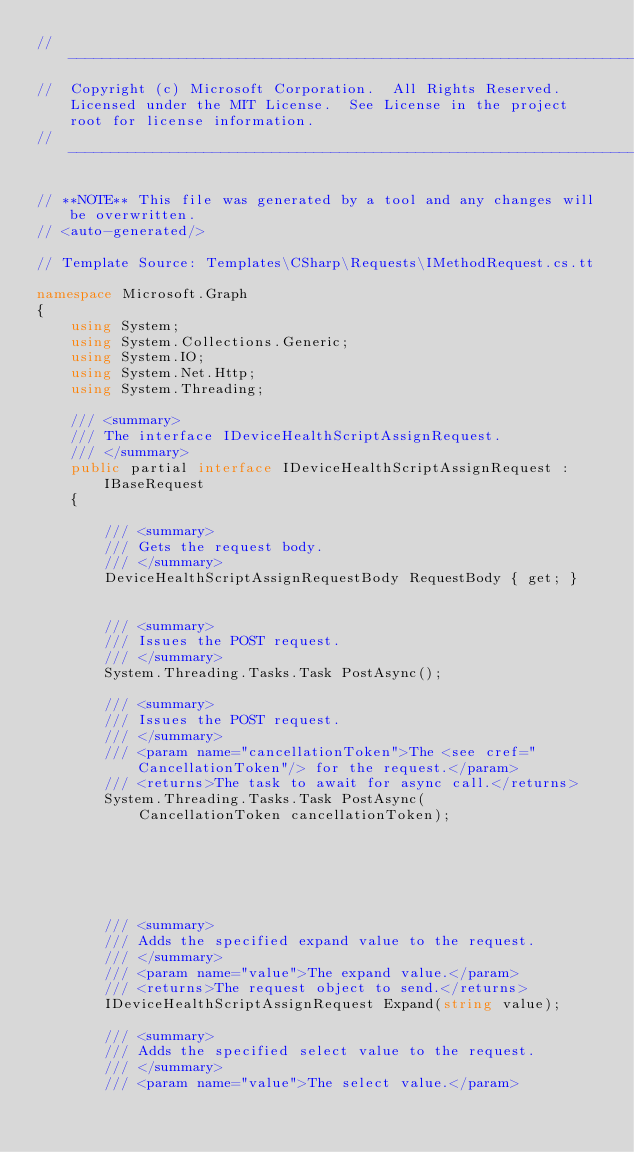<code> <loc_0><loc_0><loc_500><loc_500><_C#_>// ------------------------------------------------------------------------------
//  Copyright (c) Microsoft Corporation.  All Rights Reserved.  Licensed under the MIT License.  See License in the project root for license information.
// ------------------------------------------------------------------------------

// **NOTE** This file was generated by a tool and any changes will be overwritten.
// <auto-generated/>

// Template Source: Templates\CSharp\Requests\IMethodRequest.cs.tt

namespace Microsoft.Graph
{
    using System;
    using System.Collections.Generic;
    using System.IO;
    using System.Net.Http;
    using System.Threading;

    /// <summary>
    /// The interface IDeviceHealthScriptAssignRequest.
    /// </summary>
    public partial interface IDeviceHealthScriptAssignRequest : IBaseRequest
    {

        /// <summary>
        /// Gets the request body.
        /// </summary>
        DeviceHealthScriptAssignRequestBody RequestBody { get; }


        /// <summary>
        /// Issues the POST request.
        /// </summary>
        System.Threading.Tasks.Task PostAsync();

        /// <summary>
        /// Issues the POST request.
        /// </summary>
        /// <param name="cancellationToken">The <see cref="CancellationToken"/> for the request.</param>
        /// <returns>The task to await for async call.</returns>
        System.Threading.Tasks.Task PostAsync(
            CancellationToken cancellationToken);
        





        /// <summary>
        /// Adds the specified expand value to the request.
        /// </summary>
        /// <param name="value">The expand value.</param>
        /// <returns>The request object to send.</returns>
        IDeviceHealthScriptAssignRequest Expand(string value);

        /// <summary>
        /// Adds the specified select value to the request.
        /// </summary>
        /// <param name="value">The select value.</param></code> 